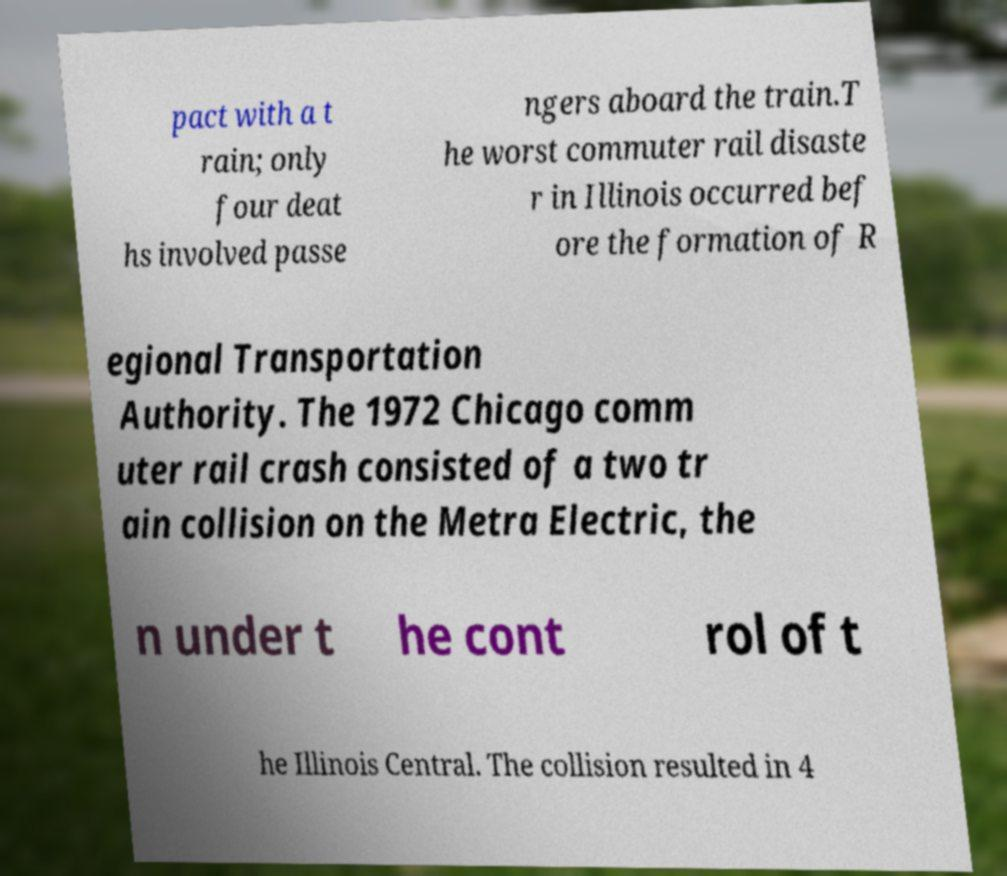For documentation purposes, I need the text within this image transcribed. Could you provide that? pact with a t rain; only four deat hs involved passe ngers aboard the train.T he worst commuter rail disaste r in Illinois occurred bef ore the formation of R egional Transportation Authority. The 1972 Chicago comm uter rail crash consisted of a two tr ain collision on the Metra Electric, the n under t he cont rol of t he Illinois Central. The collision resulted in 4 